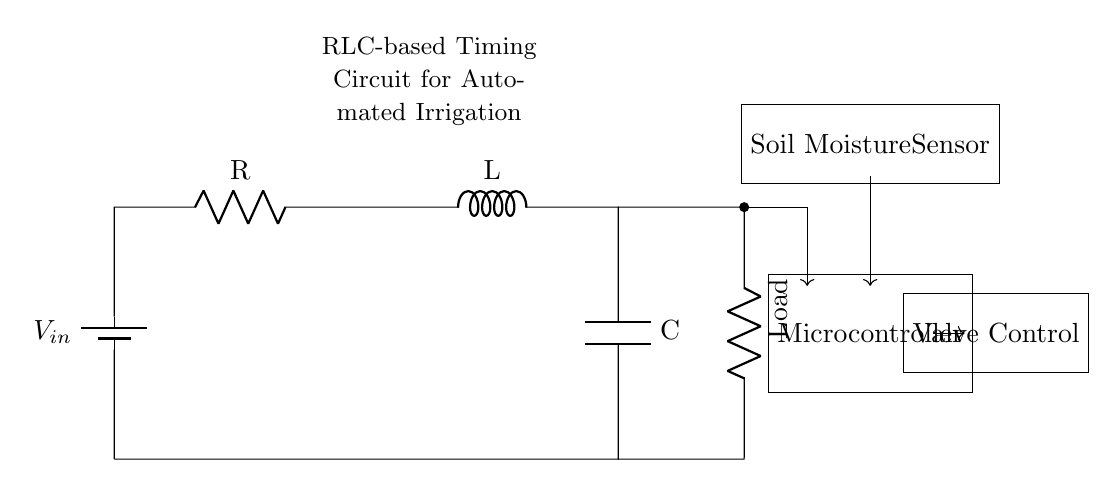What is the input voltage for this circuit? The input voltage is indicated as \( V_{in} \), which is the voltage supplied by the battery in the circuit.
Answer: \( V_{in} \) What types of components are included in this RLC circuit? The components visible in the circuit include a resistor, an inductor, and a capacitor, which are the basic elements of an RLC circuit.
Answer: Resistor, Inductor, Capacitor What is the purpose of the microcontroller in this circuit? The microcontroller manages the operation of the circuit based on input from the soil moisture sensor, activating the valve control.
Answer: Control How does the water flow through this irrigation system when activated? When the soil moisture level drops, the soil moisture sensor sends a signal to the microcontroller, which then activates the valve to allow water to flow from the source to the irrigation area.
Answer: Through the valve What is the role of the soil moisture sensor in this circuit? The soil moisture sensor detects the moisture level in the soil, providing feedback to the microcontroller to determine when to activate the irrigation system.
Answer: Feedback How does the inductor affect the timing of the irrigation system? The inductor, in conjunction with the resistor and capacitor, creates a timing circuit that can control when the irrigation system is activated based on the charging and discharging time constants of the RLC network.
Answer: Timing In what scenarios would the irrigation system need to be activated? The irrigation system is typically activated in scenarios where the soil moisture sensor detects moisture levels below a certain threshold, indicating the plants need water.
Answer: Low moisture 